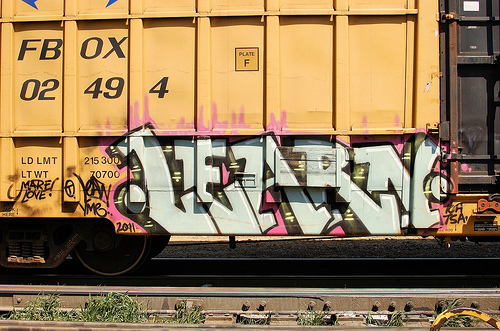<image>
Can you confirm if the painting is on the train car? Yes. Looking at the image, I can see the painting is positioned on top of the train car, with the train car providing support. 